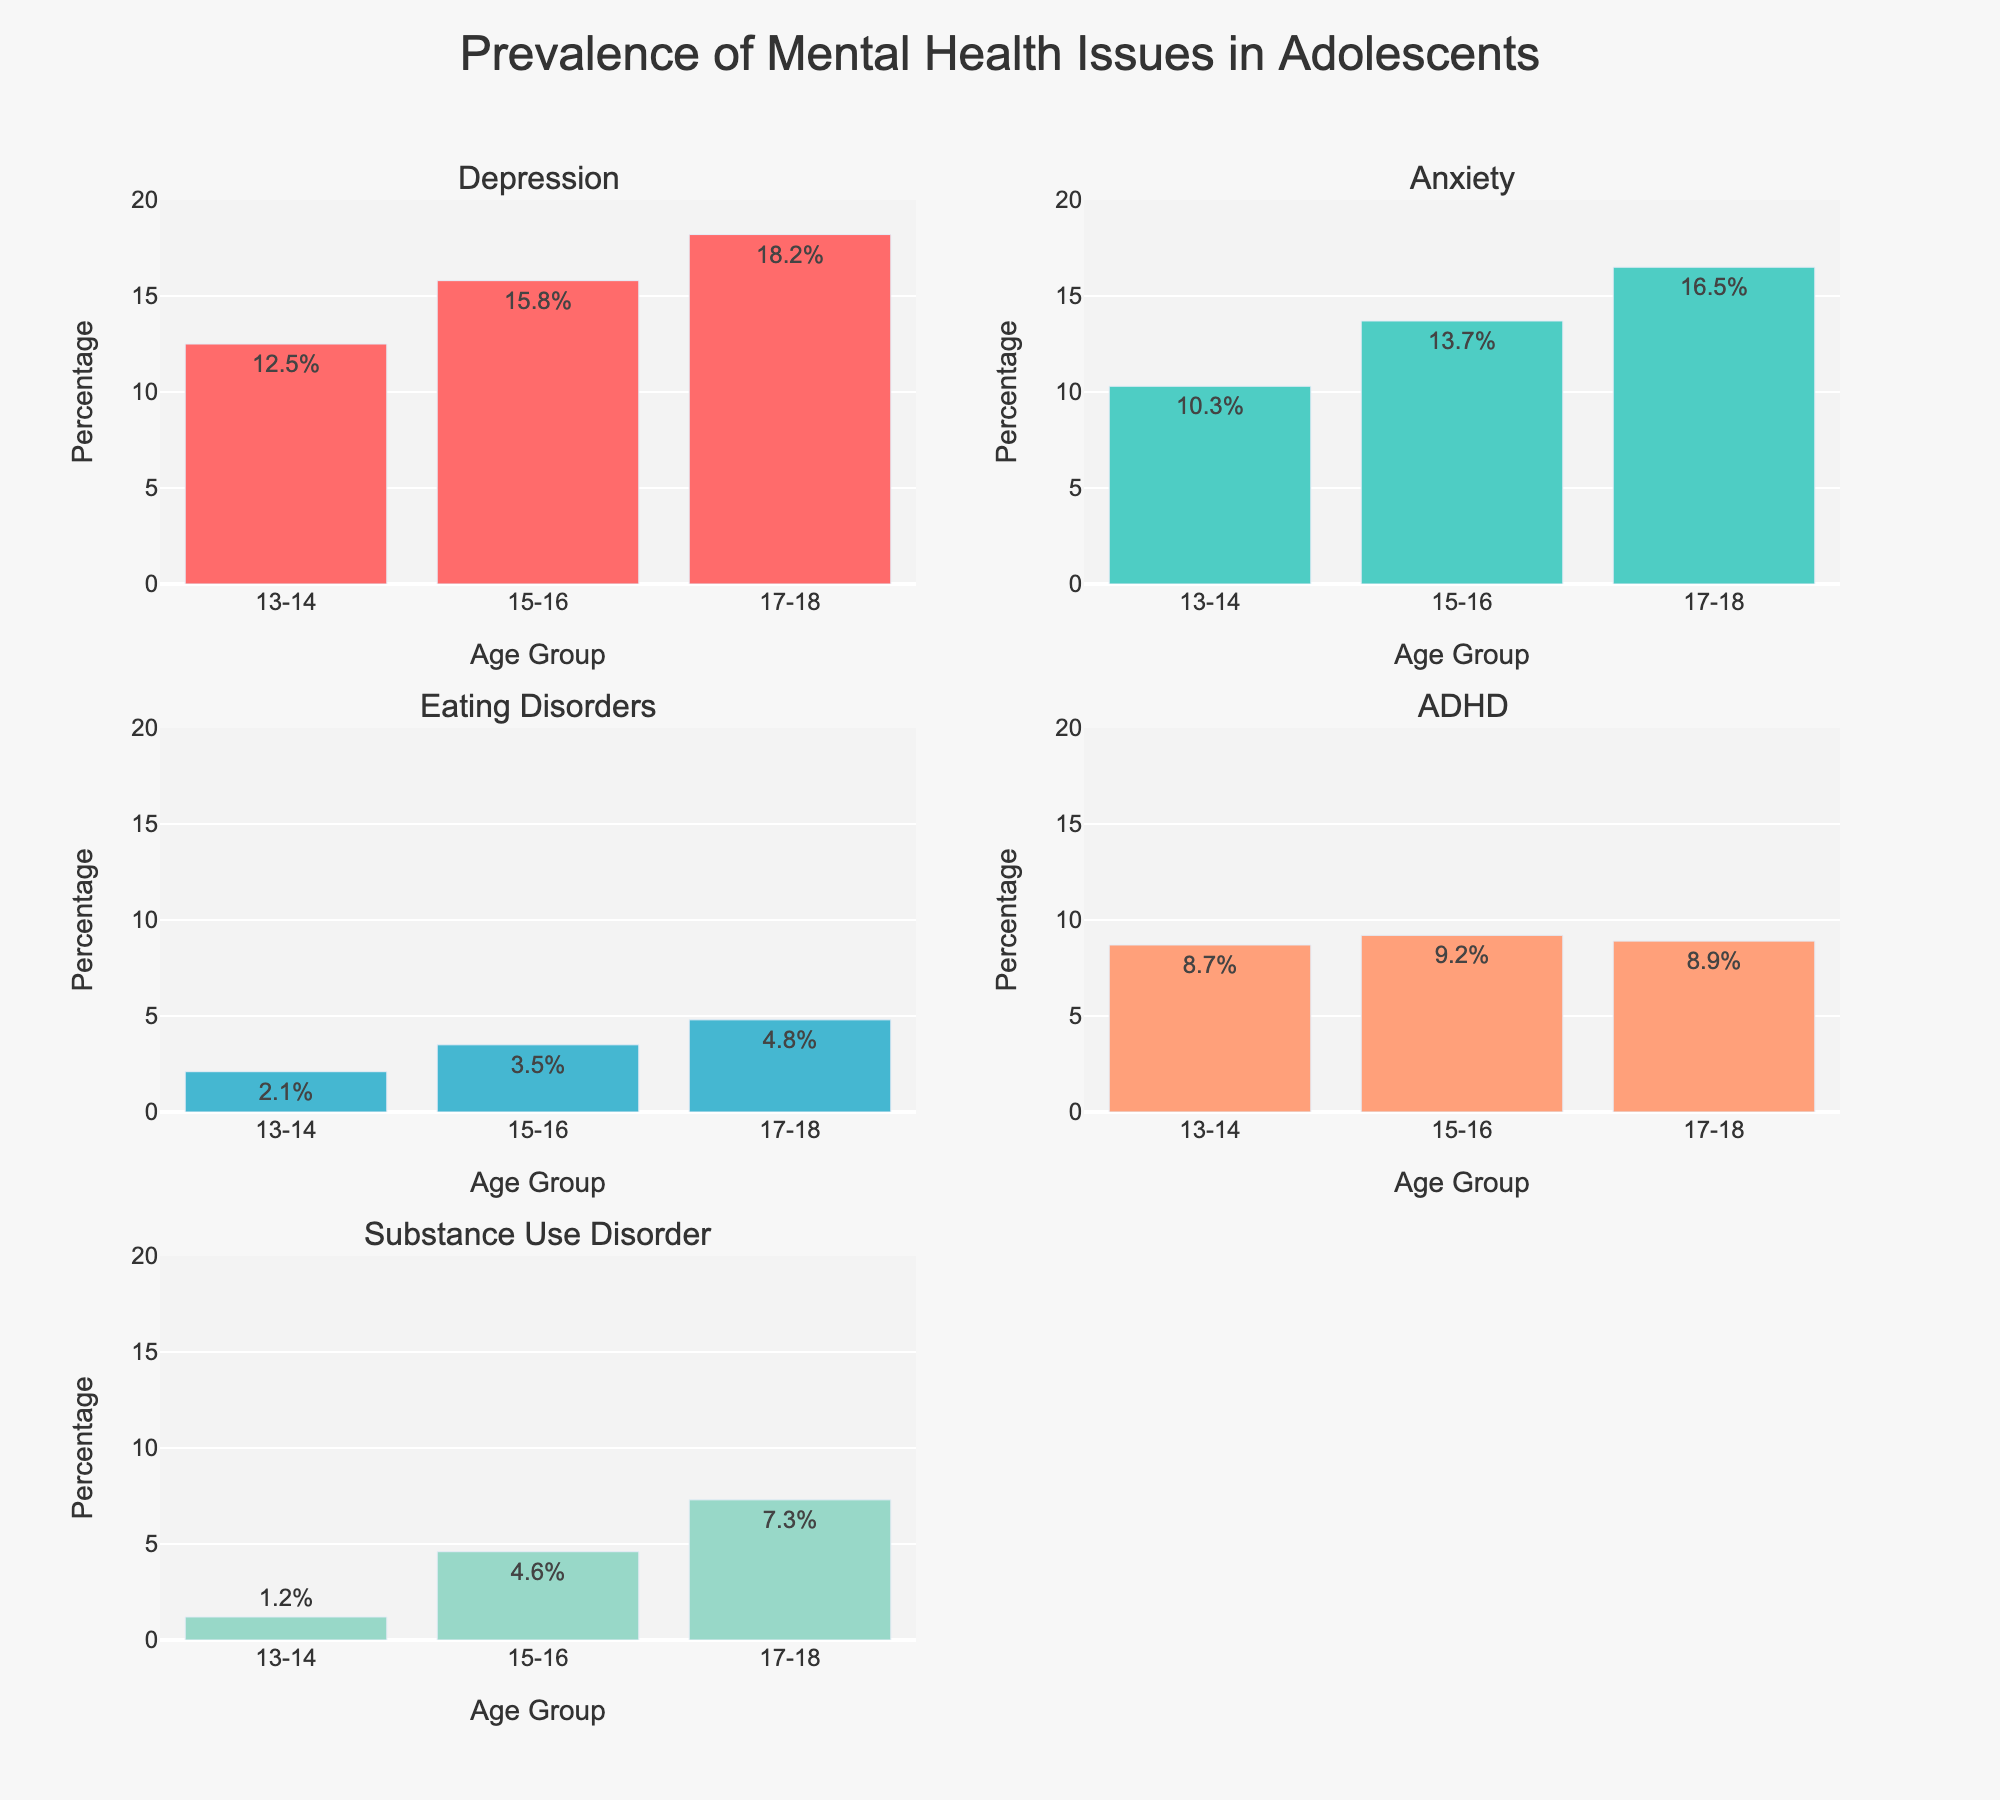What's the title of the figure? The title is usually displayed at the top of the figure. By looking at the plot, we can see the text indicating the title.
Answer: Prevalence of Mental Health Issues in Adolescents Which mental health issue has the highest percentage in the 17-18 age group? Observe each subplot related to mental health issues and compare the height of the bars for the 17-18 age group. The bar with the highest value shows the issue with the highest percentage.
Answer: Depression What is the percentage of Anxiety among 15-16-year-olds? Locate the subplot for Anxiety and find the bar corresponding to the 15-16 age group. Read the percentage value from the bar or the text label.
Answer: 13.7% How does the percentage of Eating Disorders change from ages 13-14 to 17-18? Refer to the subplot for Eating Disorders and look at the bars for both age groups. Note the values and calculate the difference to understand the change.
Answer: Increases from 2.1% to 4.8% Which age group has the lowest percentage of Substance Use Disorder? Look at the subplot for Substance Use Disorder and compare the bars for each age group. Identify the bar with the lowest percentage.
Answer: 13-14 Compare the prevalence of ADHD between the 13-14 and 15-16 age groups. In the ADHD subplot, observe the bars for the 13-14 and 15-16 age groups and note their heights or the text labels. The comparison can then be made based on these values.
Answer: 8.7% vs 9.2% What is the average percentage of Depression across all age groups? Find the values for Depression in each age group, sum them up and divide by the number of age groups to find the average.
Answer: (12.5 + 15.8 + 18.2)/3 = 15.5% Is the prevalence of ADHD higher or lower among 17-18 year-olds compared to 15-16 year-olds? Compare the bars for the 17-18 and 15-16 age groups in the ADHD subplot by checking the height of the bars or the text labels.
Answer: Lower What is the rate of increase in the percentage of Substance Use Disorder from the 13-14 age group to the 15-16 age group? Subtract the percentage of the 13-14 age group from the percentage of the 15-16 age group for Substance Use Disorder.
Answer: 4.6 - 1.2 = 3.4% Which mental health issue shows the smallest percentage increase as age progresses from 13-14 to 17-18? Identify each mental health issue and calculate the percentage increase from 13-14 to 17-18. Compare these increases to determine the smallest one.
Answer: ADHD 